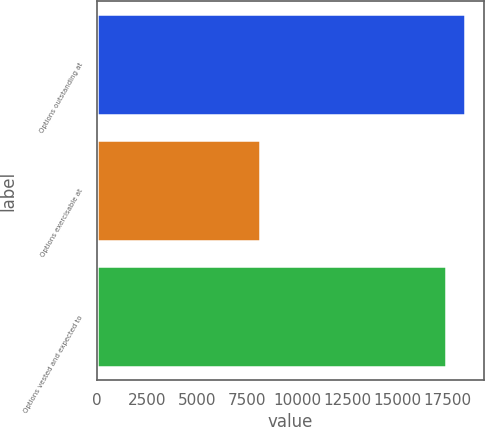Convert chart to OTSL. <chart><loc_0><loc_0><loc_500><loc_500><bar_chart><fcel>Options outstanding at<fcel>Options exercisable at<fcel>Options vested and expected to<nl><fcel>18374.8<fcel>8141<fcel>17385<nl></chart> 